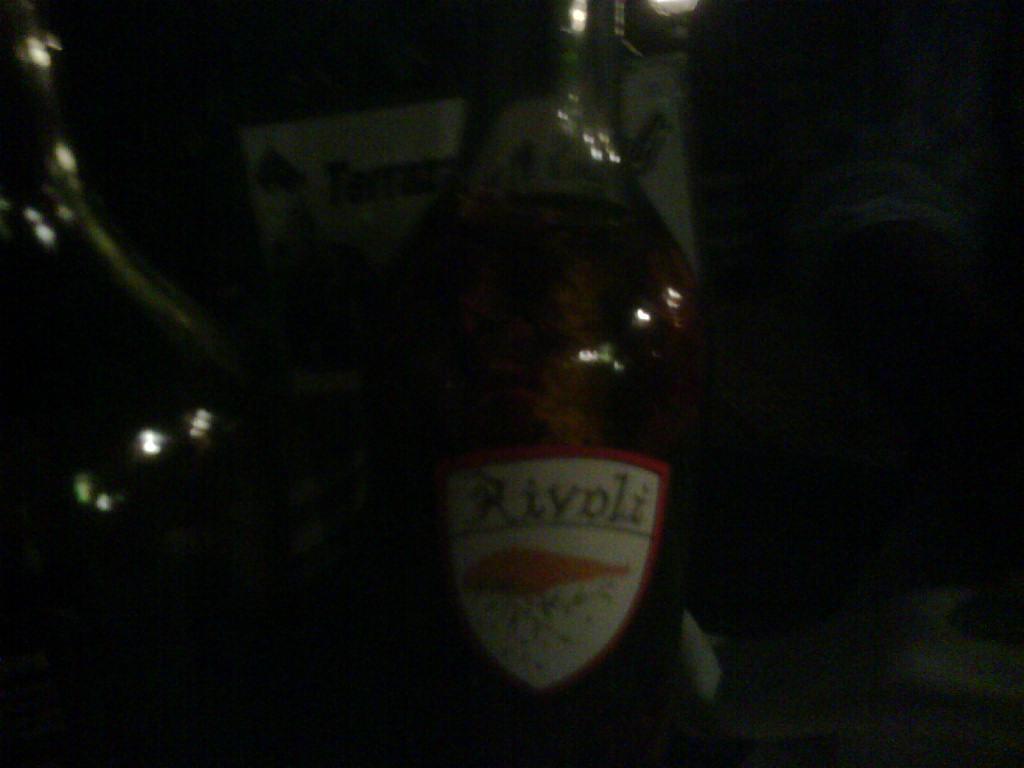Describe this image in one or two sentences. There is a bottle. The bottle has a sticker. Beside to the we have a another bottle. 